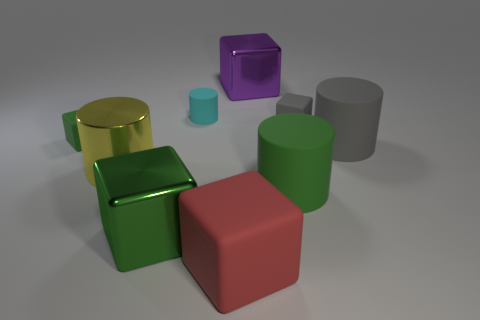What is the size of the matte thing to the left of the tiny cyan object?
Keep it short and to the point. Small. What number of cyan cylinders are the same size as the yellow metallic cylinder?
Provide a short and direct response. 0. The large cube that is the same material as the large gray cylinder is what color?
Keep it short and to the point. Red. Is the number of tiny green matte blocks left of the large yellow cylinder less than the number of tiny purple metal spheres?
Ensure brevity in your answer.  No. There is a large green thing that is made of the same material as the gray block; what is its shape?
Provide a succinct answer. Cylinder. What number of shiny things are either big objects or green cylinders?
Offer a terse response. 3. Is the number of large shiny cubes in front of the cyan cylinder the same as the number of tiny green things?
Your answer should be compact. Yes. What material is the green object that is to the left of the large red cube and behind the large green metal cube?
Give a very brief answer. Rubber. There is a purple thing that is behind the cyan object; is there a purple metal cube that is to the left of it?
Provide a succinct answer. No. Are the small cyan object and the purple block made of the same material?
Keep it short and to the point. No. 